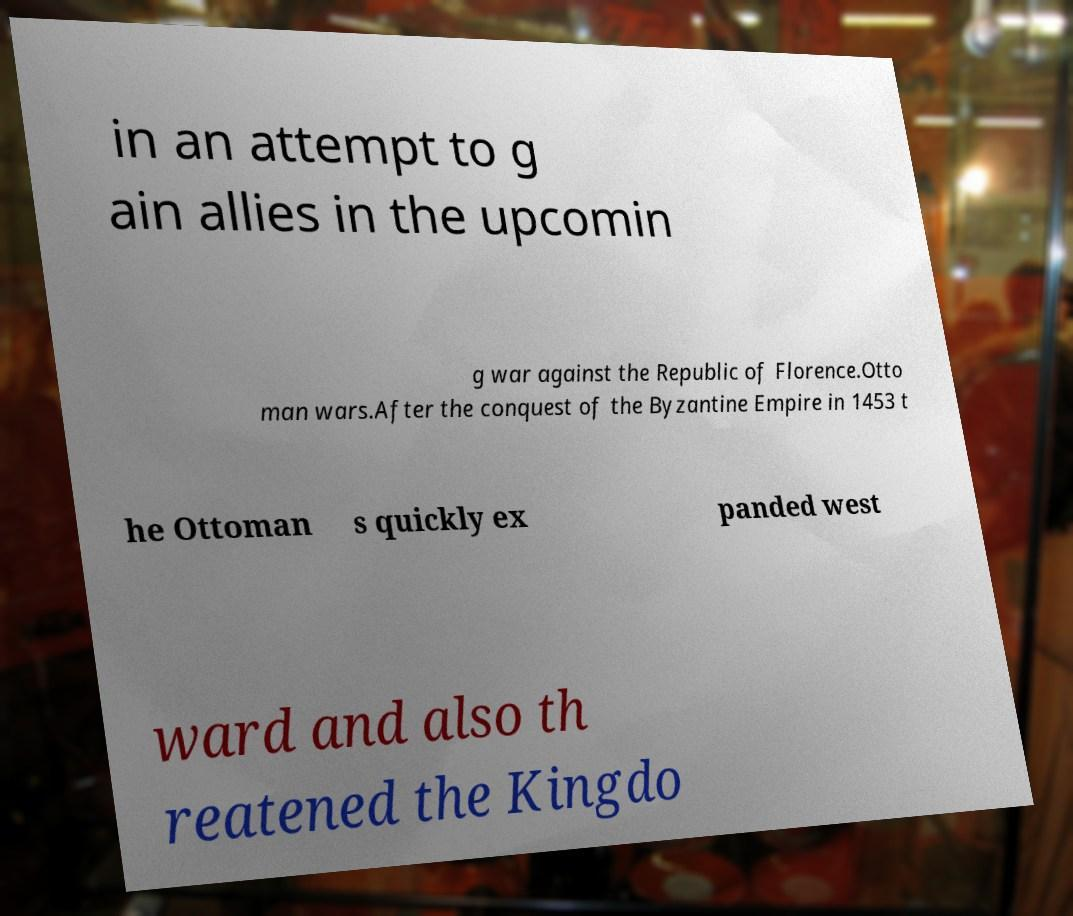Please read and relay the text visible in this image. What does it say? in an attempt to g ain allies in the upcomin g war against the Republic of Florence.Otto man wars.After the conquest of the Byzantine Empire in 1453 t he Ottoman s quickly ex panded west ward and also th reatened the Kingdo 